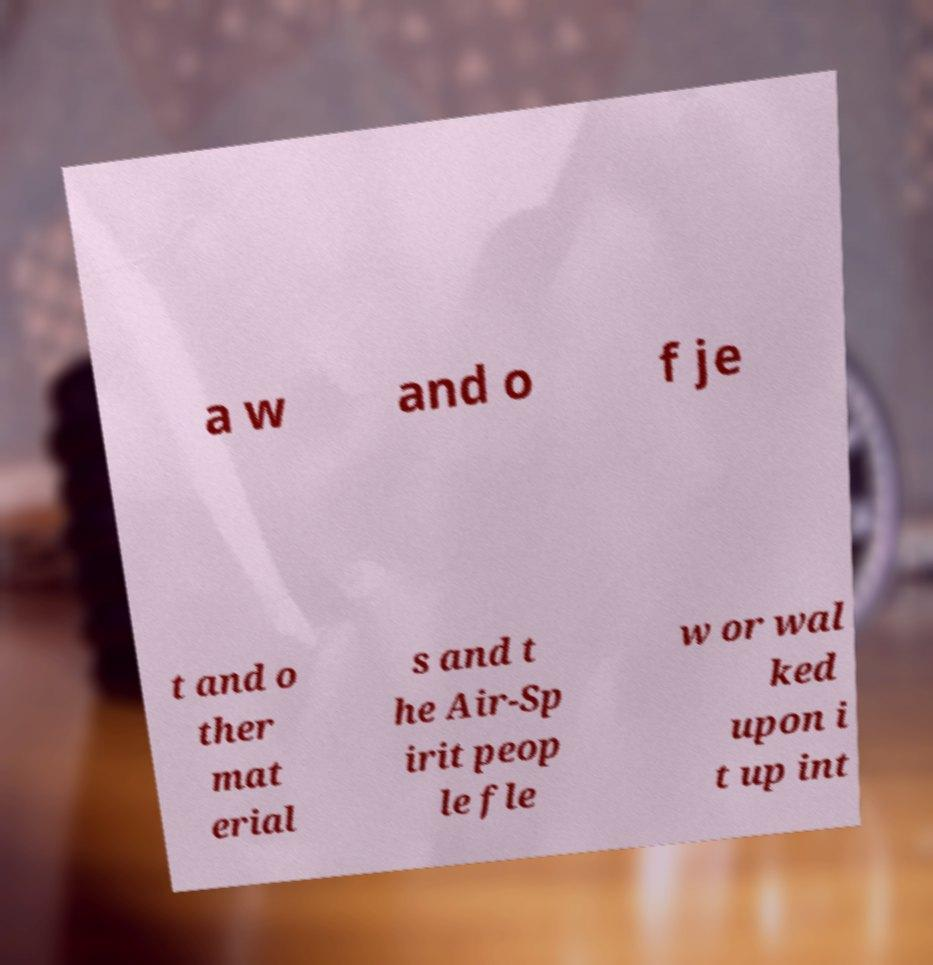Could you assist in decoding the text presented in this image and type it out clearly? a w and o f je t and o ther mat erial s and t he Air-Sp irit peop le fle w or wal ked upon i t up int 